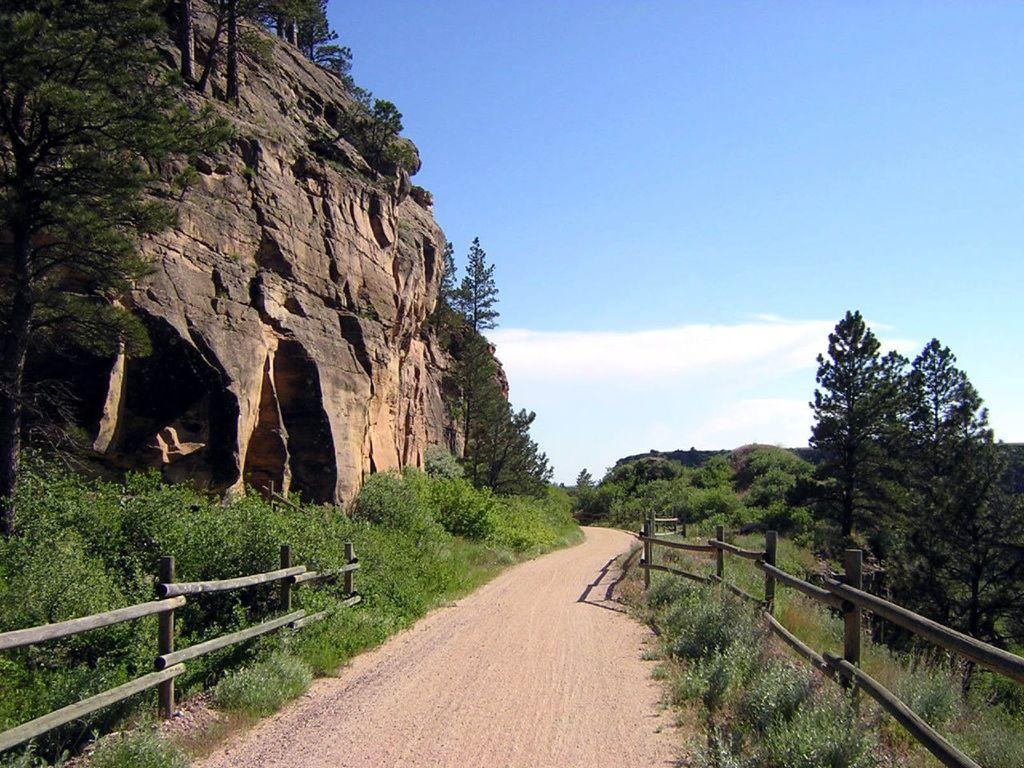Describe this image in one or two sentences. In the image we can see rock, trees, plants and the grass. We can even see a path, wooden fence and the cloudy pale blue sky. 